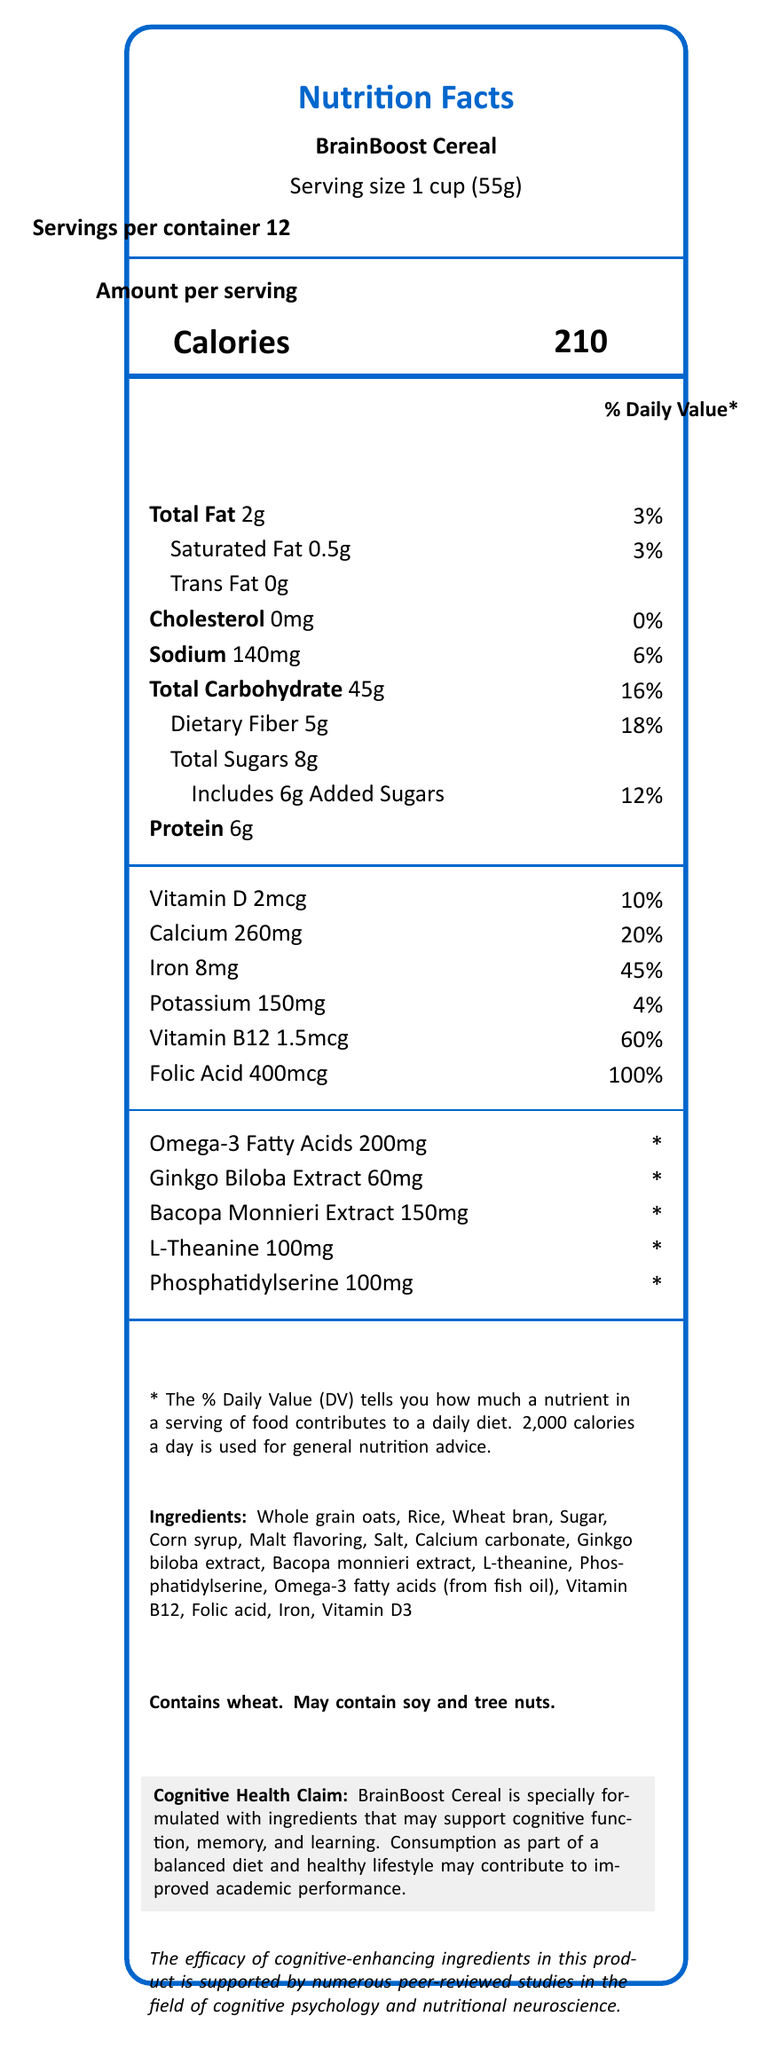what is the serving size for BrainBoost Cereal? The serving size is clearly mentioned in the document as "Serving size 1 cup (55g)".
Answer: 1 cup (55g) how many servings are there per container? The document states "Servings per container 12."
Answer: 12 how many calories are in one serving of BrainBoost Cereal? The document lists "Calories 210" for one serving.
Answer: 210 how much protein is in one serving of BrainBoost Cereal? The document indicates "Protein 6g" in one serving.
Answer: 6g what is the dietary fiber content in one serving? The document indicates "Dietary Fiber 5g."
Answer: 5g what percentage of daily value of Iron does one serving provide? A. 20% B. 30% C. 45% D. 60% The document shows that one serving provides "Iron 8mg" which is "45% Daily Value."
Answer: C how much Calcium is in one serving? A. 150mg B. 200mg C. 260mg D. 300mg The document specifies "Calcium 260mg."
Answer: C does the product contain trans fat? The document lists "Trans Fat 0g," so the product does not contain trans fat.
Answer: No is there any cholesterol in BrainBoost Cereal? The document states "Cholesterol 0mg," indicating there is no cholesterol.
Answer: No does the BrainBoost Cereal contain any allergens? The label indicates "Contains wheat. May contain soy and tree nuts."
Answer: Yes list three cognitive-enhancing ingredients in this cereal These ingredients are mentioned in the document under special ingredients that support cognitive health.
Answer: Ginkgo Biloba Extract, Bacopa Monnieri Extract, L-Theanine how much Vitamin B12 is in one serving? The document lists "Vitamin B12 1.5mcg."
Answer: 1.5mcg what is the total carbohydrate content per serving? The document specifies "Total Carbohydrate 45g."
Answer: 45g what is the main purpose of BrainBoost Cereal according to the document? The document's cognitive health claim states that BrainBoost Cereal is formulated to support cognitive function, memory, and learning.
Answer: Support cognitive function, memory, and learning is the efficacy of cognitive-enhancing ingredients in this product supported by scientific research? The document mentions that the efficacy is supported by numerous peer-reviewed studies in cognitive psychology and nutritional neuroscience.
Answer: Yes how much Ginkgo Biloba Extract is added per serving? The document states "Ginkgo Biloba Extract 60mg."
Answer: 60mg write a brief summary of the BrainBoost Cereal Nutrition Facts Label. The document outlines the nutritional content, serving size, key ingredients, cognitive health claims, and potential allergens of BrainBoost Cereal.
Answer: BrainBoost Cereal, a fortified breakfast cereal, provides nutritional information for a serving size of 1 cup (55g) out of 12 servings per container. Each serving contains 210 calories, 2g of total fat, 45g of carbohydrates, 5g of dietary fiber, 8g of total sugars (including 6g added sugars), and 6g of protein. It also offers several vitamins and minerals essential for cognitive health, including significant amounts of Iron, Calcium, Vitamin B12, and Folic Acid. Additionally, it contains specialized ingredients like Ginkgo Biloba Extract, Bacopa Monnieri Extract, L-Theanine, Phosphatidylserine, and Omega-3 fatty acids for cognitive support. The document includes a disclaimer about the daily values and mentions potential allergens. The product claims to enhance cognitive function, supported by scientific research. what is the brand name of the fortified breakfast cereal? The document only mentions the product name "BrainBoost Cereal" but does not specify the brand name.
Answer: Cannot be determined 